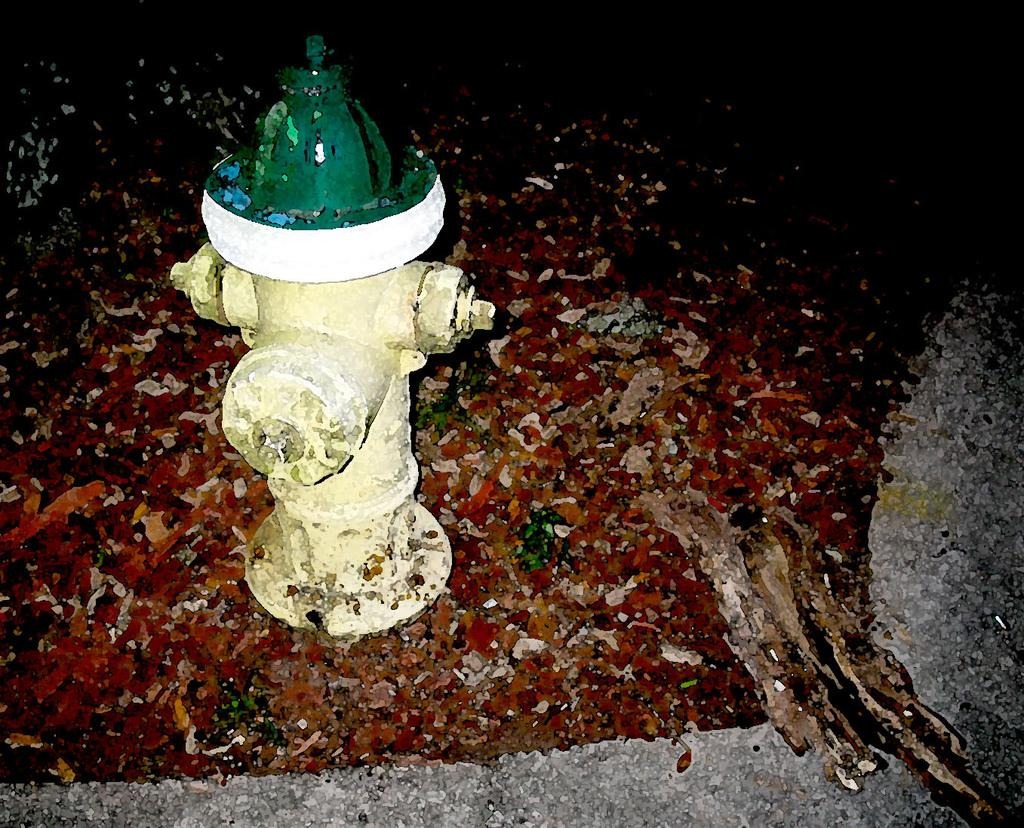What object is the main subject of the image? There is a fire hydrant in the image. What can be observed about the area surrounding the fire hydrant? The surface around the fire hydrant is colorful. What type of cart is being pulled by the zephyr in the image? There is no cart or zephyr present in the image; it only features a fire hydrant and a colorful surface. 